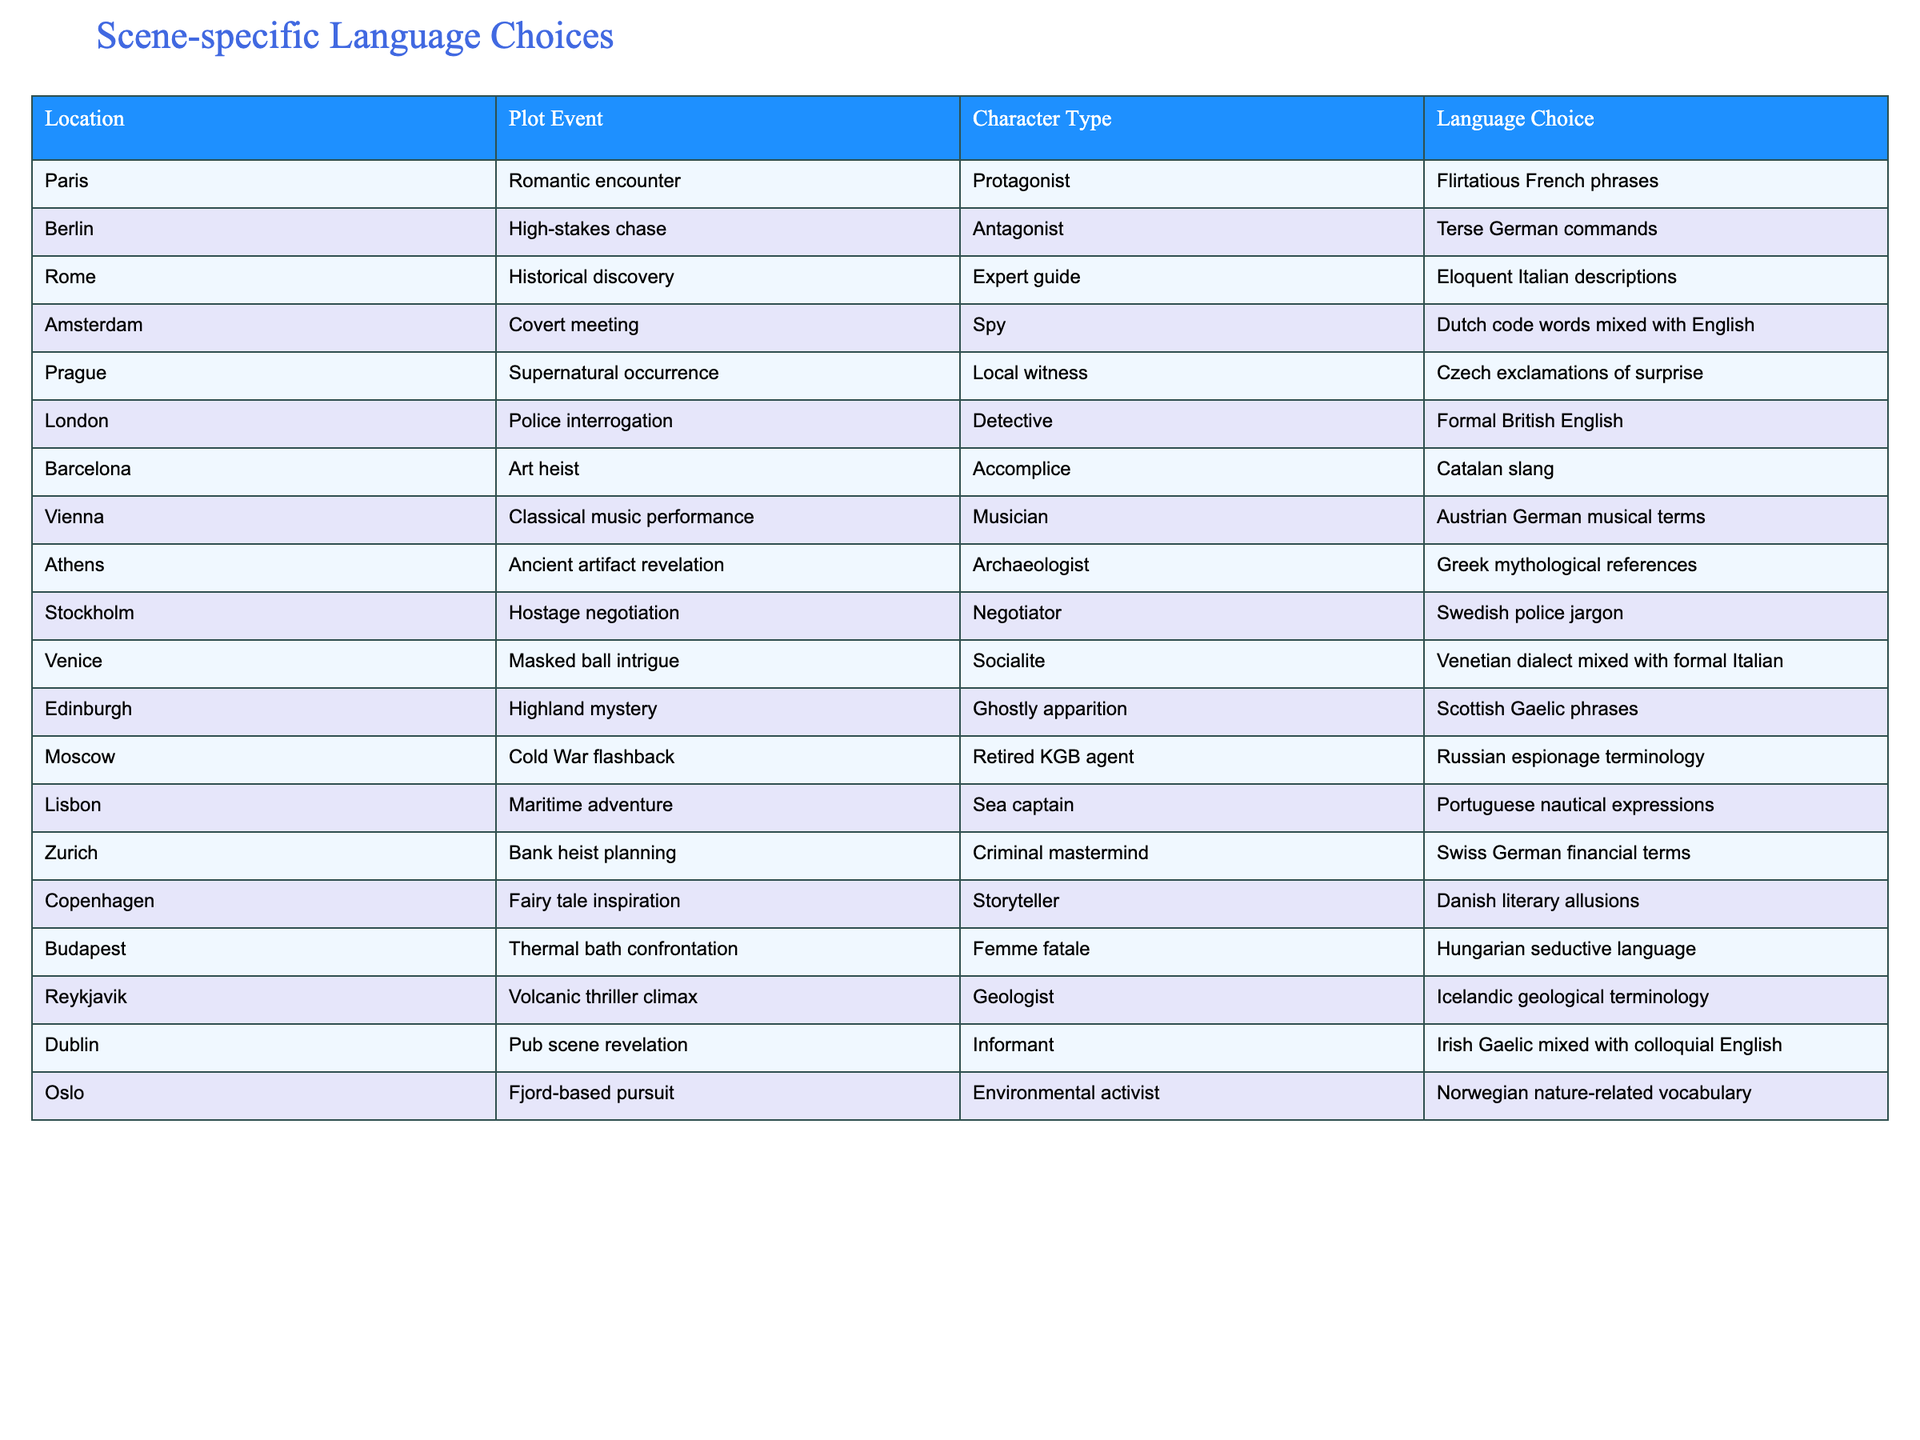What language choice is used in Venice during the masked ball intrigue? The table states that during the masked ball intrigue in Venice, the language choice is "Venetian dialect mixed with formal Italian." This is directly retrievable from the "Location" and "Language Choice" columns in the relevant row.
Answer: Venetian dialect mixed with formal Italian Which character type uses German commands in Berlin? In Berlin, the character type that uses terse German commands is the Antagonist, as clearly indicated in both the "Plot Event" and "Character Type" columns for that location.
Answer: Antagonist How many different languages are associated with the high-stakes chase in Berlin? The only language associated with the high-stakes chase in Berlin is terse German commands. Therefore, the count of different languages is just one, as there are no other languages mentioned in that specific row.
Answer: 1 True or false: The protagonist in Paris uses Italian phrases. According to the table, the protagonist in Paris uses "Flirtatious French phrases," not Italian. Therefore, the statement is false.
Answer: False In which locations do spies use language related to their profession? Analyzing the table, the Spy in Amsterdam uses "Dutch code words mixed with English," and there is also a character type in Zurich labeled as a "Criminal mastermind," who employs "Swiss German financial terms." Therefore, both Amsterdam and Zurich feature language choices relevant to spies.
Answer: Amsterdam and Zurich What is the language choice for the character involved in the ancient artifact revelation in Athens? The character involved in the ancient artifact revelation in Athens, an Archaeologist, uses "Greek mythological references." This is found in the "Language Choice" column corresponding to the "Plot Event" and "Character Type."
Answer: Greek mythological references How does the language choice for the socialite in Venice compare to that of the expert guide in Rome? The language choice for the socialite in Venice is "Venetian dialect mixed with formal Italian," while the expert guide in Rome uses "Eloquent Italian descriptions." Both choices stem from the same root language (Italian), but the Venice choice incorporates dialect, whereas the Rome choice emphasizes eloquence.
Answer: Different, Venetian dialect vs Eloquent Italian List the languages used by characters in seaside or waterfront settings. In seaside or waterfront settings, the Sea captain in Lisbon uses "Portuguese nautical expressions," while the character involved in a fjord-based pursuit in Oslo employs "Norwegian nature-related vocabulary." Therefore, the relevant languages are Portuguese and Norwegian.
Answer: Portuguese and Norwegian Which two character types are involved in confrontations in Budapest and Prague? The character in Budapest is a Femme fatale using "Hungarian seductive language," while in Prague, the Local witness, in response to a supernatural occurrence, uses "Czech exclamations of surprise." Both characters are involved in confrontational plot events.
Answer: Femme fatale and Local witness 